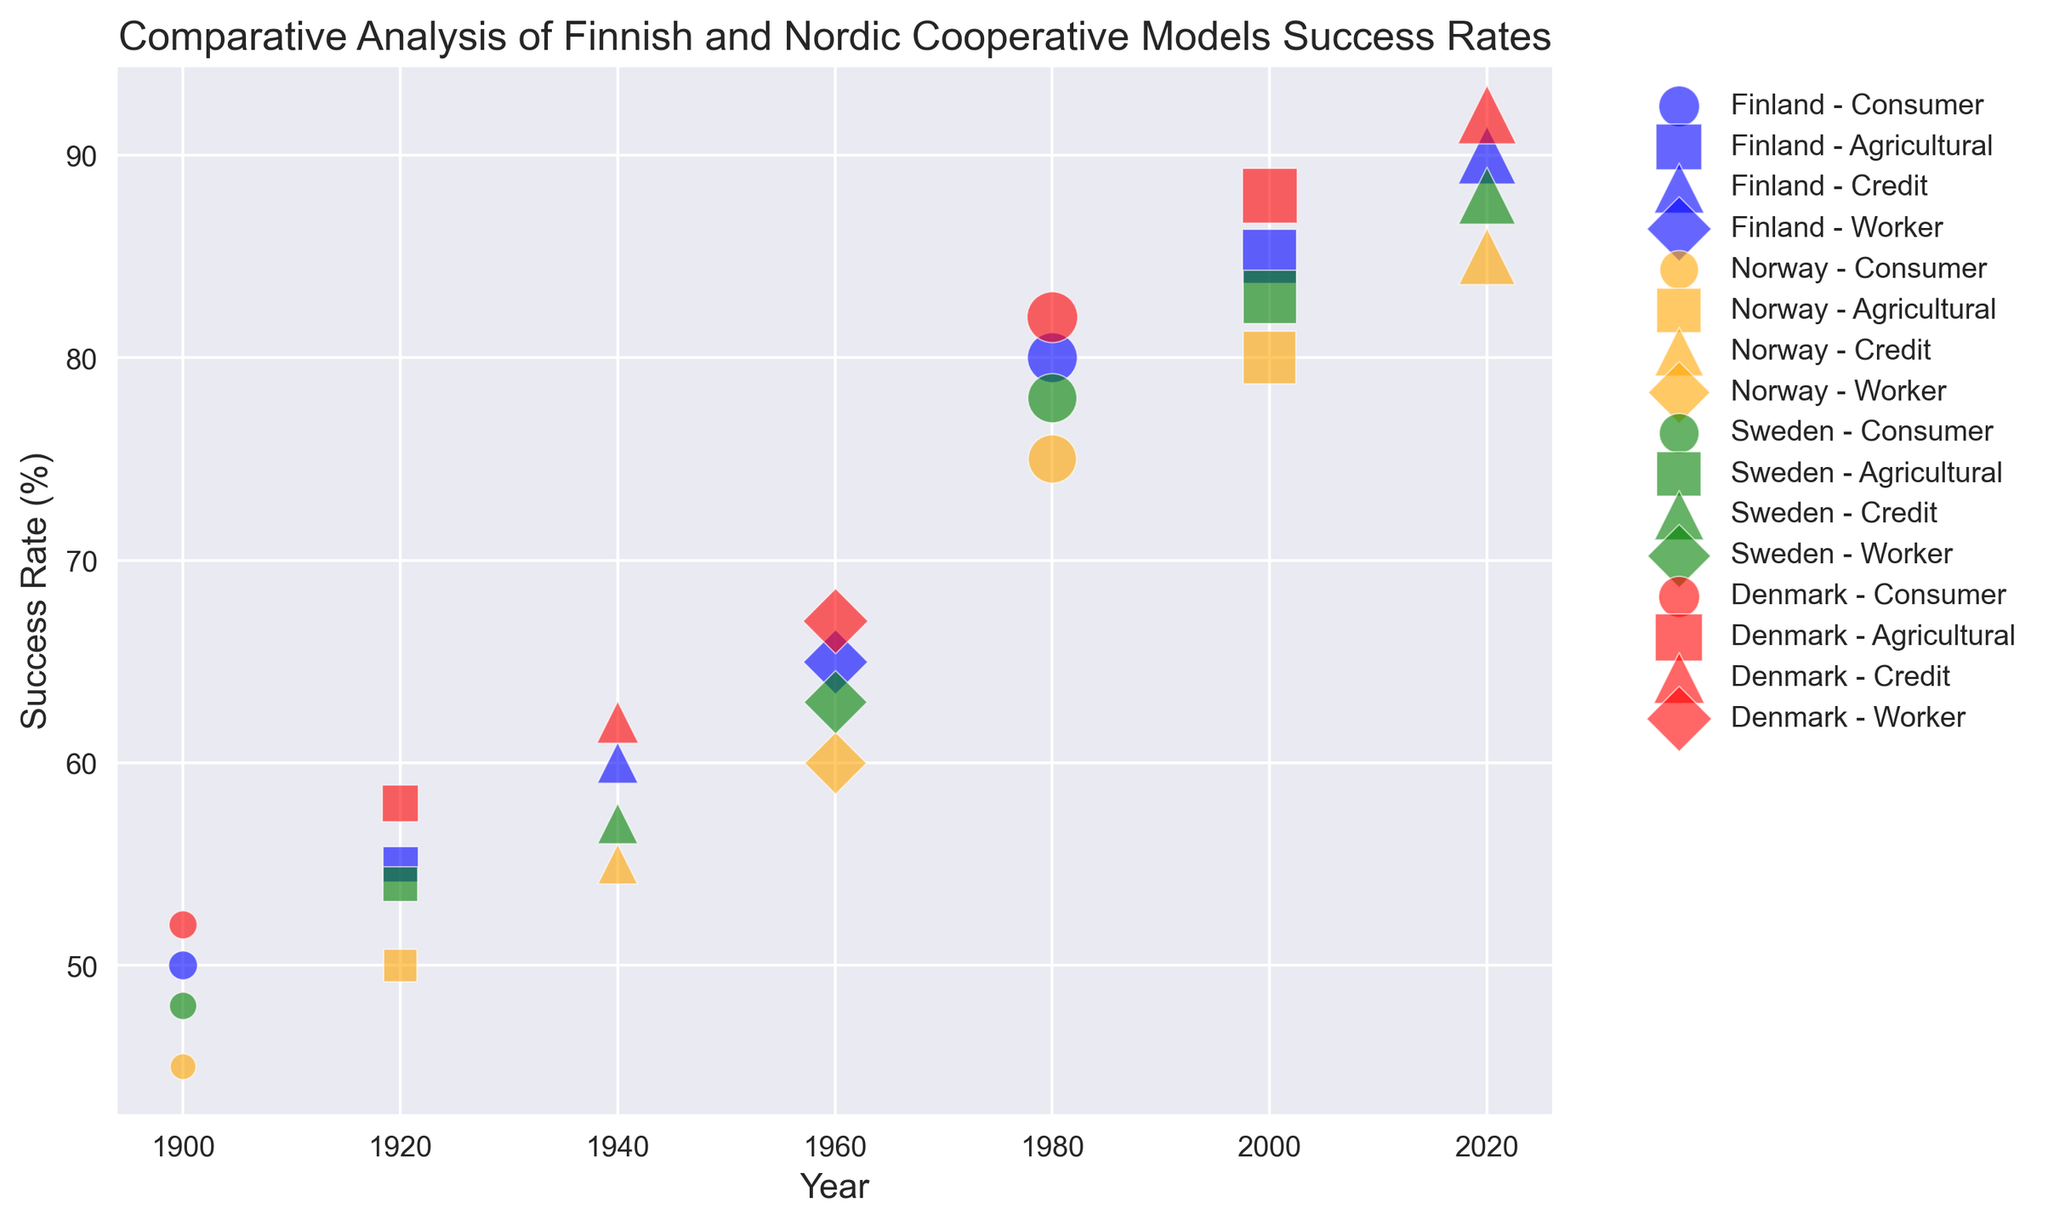What's the country with the highest success rate in 2020 for Credit cooperatives? Look at the year 2020 and identify the different countries under the Credit cooperative type. Compare the success rates and find the highest. Denmark has a success rate of 92%, which is the highest among the countries.
Answer: Denmark Which Finnish cooperative type had the highest membership retention in the 2000s? Focus on the year 2000 for Finland and compare the membership retention rates across different cooperative types. The Agricultural type had the highest retention rate at 92%.
Answer: Agricultural What is the trend in the number of cooperative establishments in Finland from 1900 to 2020? Observe the increasing sizes of the bubbles for Finland, which represents the number of establishments over the years. The trend shows a gradual increase, indicating that the number of cooperative establishments in Finland has been rising.
Answer: Increasing How does the success rate of Danish consumer cooperatives in 1980 compare to Norwegian consumer cooperatives in the same year? Look at the year 1980, and compare the success rates between Danish and Norwegian consumer cooperatives. Denmark has a success rate of 82%, while Norway has 75%. The Danish success rate is higher.
Answer: Denmark has a higher success rate What is the difference in the number of establishments between Finnish Credit cooperatives in 1940 and 2020? For Finland, find the number of establishments for Credit cooperatives in 1940 and 2020, then calculate the difference. The numbers are 200 in 1940 and 400 in 2020 respectively. The difference is 400 - 200 = 200.
Answer: 200 Which cooperative type has consistently shown the highest success rate across all countries and years? Compare success rates of all cooperative types across all years and countries. The Credit cooperative type consistently shows higher success rates in the later years, especially in 2020.
Answer: Credit What is the largest bubble in the year 1960 and which country does it represent? Find the largest bubble for the year 1960, which indicates the highest number of establishments. The largest bubble is for Denmark.
Answer: Denmark How did the membership retention rate change for Finnish agricultural cooperatives from 1920 to 2000? Examine the membership retention rates for agricultural cooperatives in Finland in 1920 and 2000. The rates are 75% in 1920 and 92% in 2000.
Answer: Increased What are the average values of success rates for Worker cooperatives across the Nordic countries in 1960? Find success rates for Worker cooperatives in Denmark, Finland, Norway, and Sweden for the year 1960. The rates are 65% (Finland), 60% (Norway), 63% (Sweden), and 67% (Denmark). The average is (65 + 60 + 63 + 67)/4 = 63.75.
Answer: 63.75 Which country has the most visually balanced number of cooperative establishments and success rates across all cooperative types in 1980? In 1980, compare the sizes of the bubbles (number of establishments) and positions (success rates) across all cooperative types for each country. Denmark has balanced high success rates and a high number of establishments across all cooperative types.
Answer: Denmark 